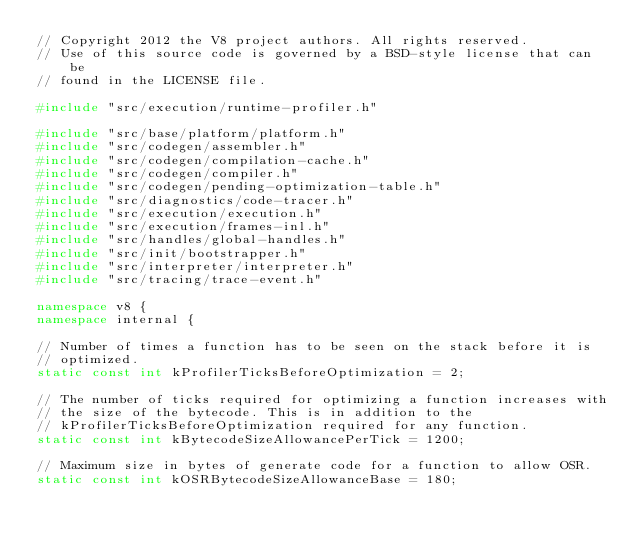Convert code to text. <code><loc_0><loc_0><loc_500><loc_500><_C++_>// Copyright 2012 the V8 project authors. All rights reserved.
// Use of this source code is governed by a BSD-style license that can be
// found in the LICENSE file.

#include "src/execution/runtime-profiler.h"

#include "src/base/platform/platform.h"
#include "src/codegen/assembler.h"
#include "src/codegen/compilation-cache.h"
#include "src/codegen/compiler.h"
#include "src/codegen/pending-optimization-table.h"
#include "src/diagnostics/code-tracer.h"
#include "src/execution/execution.h"
#include "src/execution/frames-inl.h"
#include "src/handles/global-handles.h"
#include "src/init/bootstrapper.h"
#include "src/interpreter/interpreter.h"
#include "src/tracing/trace-event.h"

namespace v8 {
namespace internal {

// Number of times a function has to be seen on the stack before it is
// optimized.
static const int kProfilerTicksBeforeOptimization = 2;

// The number of ticks required for optimizing a function increases with
// the size of the bytecode. This is in addition to the
// kProfilerTicksBeforeOptimization required for any function.
static const int kBytecodeSizeAllowancePerTick = 1200;

// Maximum size in bytes of generate code for a function to allow OSR.
static const int kOSRBytecodeSizeAllowanceBase = 180;
</code> 